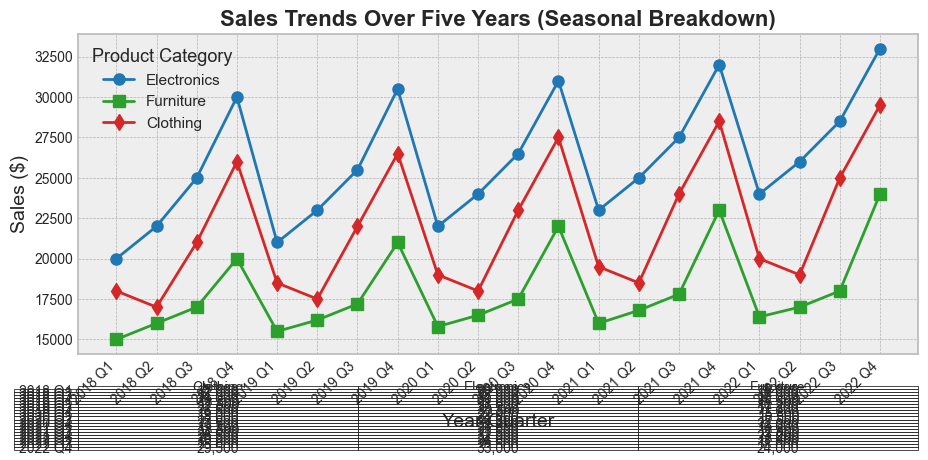What is the trend in Electronics sales from Q1 2018 to Q4 2022? Inspect Electronics sales data points from Q1 2018 to Q4 2022 on the plot. Notice the sales values are increasing over these quarters.
Answer: Increasing Which product category had the highest sales in Q3 2021? Compare the sales values for Electronics, Furniture, and Clothing in Q3 2021. Electronics had the highest sales value.
Answer: Electronics By how much did Clothing sales increase from Q3 2021 to Q3 2022? Locate the sales values for Clothing in Q3 2021 and Q3 2022 on the plot. Subtract the Q3 2021 value (24,000) from the Q3 2022 value (25,000) to get the increase (25,000 - 24,000).
Answer: 1,000 Which product category shows the highest seasonal variability? Look for product categories with significant fluctuations between quarters within each year. Electronics shows the highest seasonal variability with visible peaks in Q4.
Answer: Electronics What is the average quarterly sales for Furniture over the five years shown? Sum the sales values for Furniture over all quarters (15,000 + 16,000 + ... + 24,000) and divide by the total number of quarters (20).
Answer: 18,250 In which quarter and year did Electronics have its highest sales? Find the highest sales value in the Electronics data series and locate the corresponding quarter and year.
Answer: Q4 2022 Between which consecutive quarters was the largest increase in Furniture sales observed? Calculate the differences in sales values between all consecutive quarters for Furniture and find the pair with the largest increase, which is from Q4 2021 to Q1 2022 (23,000 to 24,000).
Answer: Q4 2021 to Q1 2022 What percentage of total yearly sales in 2020 was contributed by Electronics? First, sum the total sales for all categories in 2020. Then sum only the Electronics sales for 2020. Divide the Electronics total by the overall total and multiply by 100. Overall total = (22,000 + 15,800 + ... + 27,500). Electronics total = (22,000 + 23,000 + ... + 31,000). (116,500 / 195,600) * 100 ≈ 59.55%
Answer: 59.55% How did the sales trends for Furniture and Clothing compare in Q2 2022? Examine the Q2 2022 sales data for both categories on the plot. Furniture shows 17,000 while Clothing shows 19,000 indicating Clothing outperformed Furniture.
Answer: Clothing outperformed Furniture in Q2 2022 